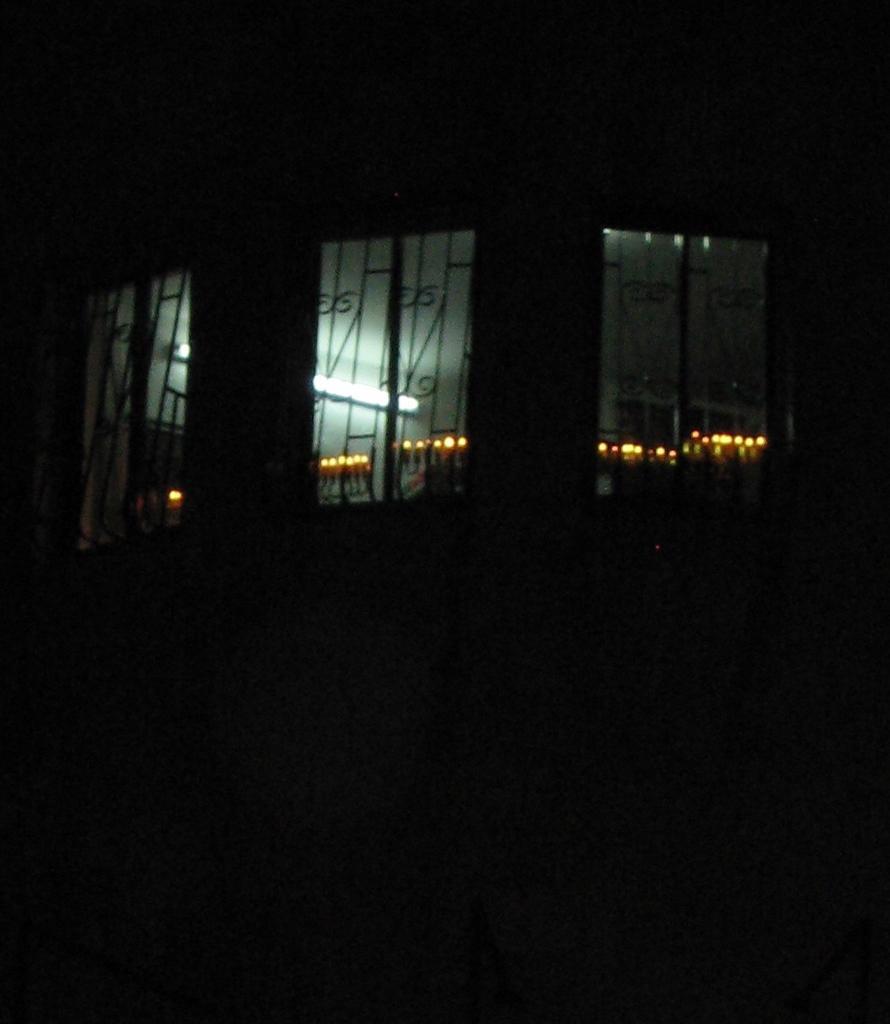Describe this image in one or two sentences. This picture is dark, in this image in the center there are three windows visible, and through the windows we could see some lights and wall. 